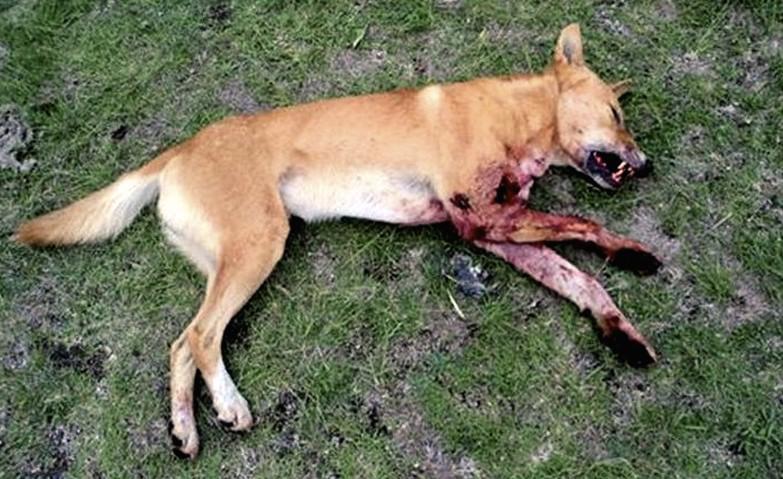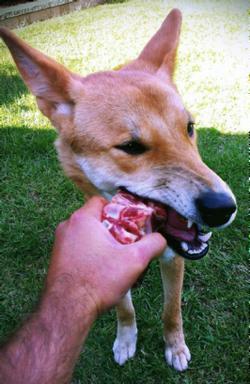The first image is the image on the left, the second image is the image on the right. For the images shown, is this caption "There is a single tan and white canine facing left standing on the tan and green grass." true? Answer yes or no. No. The first image is the image on the left, the second image is the image on the right. Assess this claim about the two images: "In the left image, a lone dog stands up, and is looking right at the camera.". Correct or not? Answer yes or no. No. 